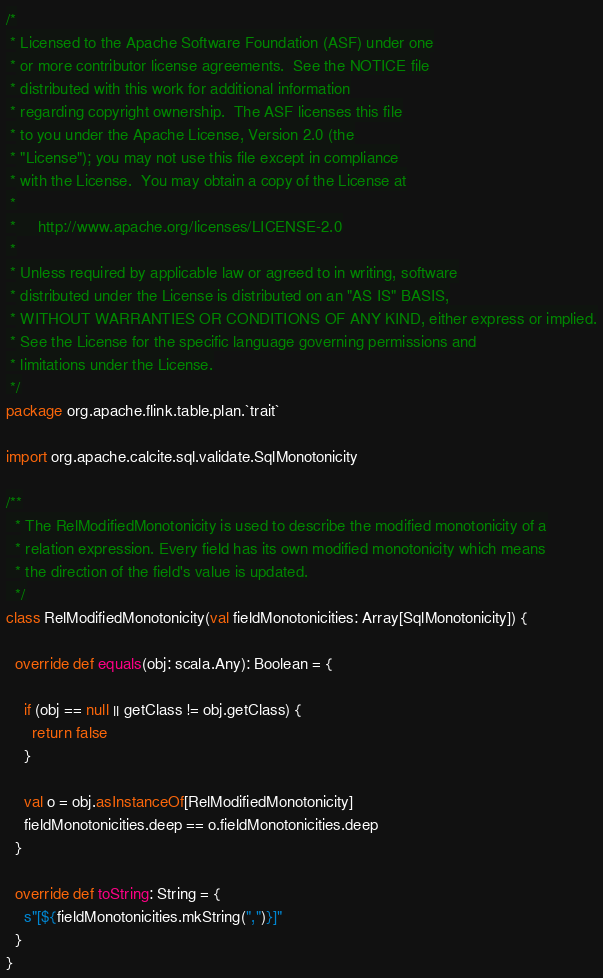Convert code to text. <code><loc_0><loc_0><loc_500><loc_500><_Scala_>/*
 * Licensed to the Apache Software Foundation (ASF) under one
 * or more contributor license agreements.  See the NOTICE file
 * distributed with this work for additional information
 * regarding copyright ownership.  The ASF licenses this file
 * to you under the Apache License, Version 2.0 (the
 * "License"); you may not use this file except in compliance
 * with the License.  You may obtain a copy of the License at
 *
 *     http://www.apache.org/licenses/LICENSE-2.0
 *
 * Unless required by applicable law or agreed to in writing, software
 * distributed under the License is distributed on an "AS IS" BASIS,
 * WITHOUT WARRANTIES OR CONDITIONS OF ANY KIND, either express or implied.
 * See the License for the specific language governing permissions and
 * limitations under the License.
 */
package org.apache.flink.table.plan.`trait`

import org.apache.calcite.sql.validate.SqlMonotonicity

/**
  * The RelModifiedMonotonicity is used to describe the modified monotonicity of a
  * relation expression. Every field has its own modified monotonicity which means
  * the direction of the field's value is updated.
  */
class RelModifiedMonotonicity(val fieldMonotonicities: Array[SqlMonotonicity]) {

  override def equals(obj: scala.Any): Boolean = {

    if (obj == null || getClass != obj.getClass) {
      return false
    }

    val o = obj.asInstanceOf[RelModifiedMonotonicity]
    fieldMonotonicities.deep == o.fieldMonotonicities.deep
  }

  override def toString: String = {
    s"[${fieldMonotonicities.mkString(",")}]"
  }
}
</code> 